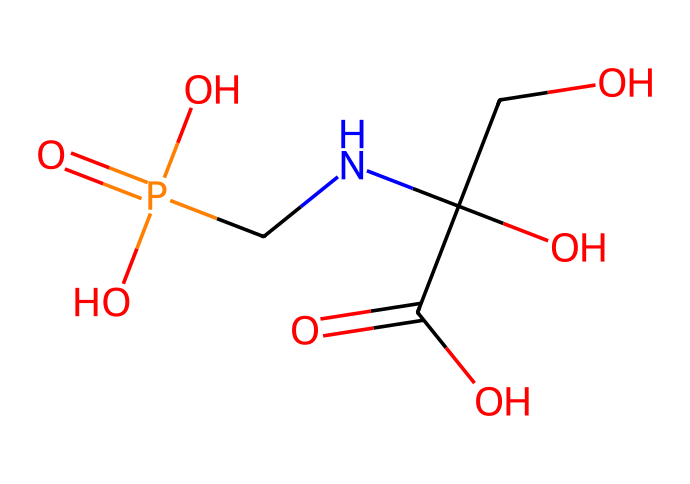How many carbon atoms are in glyphosate? The SMILES representation shows the presence of four carbon atoms in glyphosate, indicated by "C" in the structure. Counting each "C" gives the total number.
Answer: four What functional groups are present in glyphosate? Examining the SMILES, glyphosate contains a carboxylic acid (-COOH) group and an amine (-NH) group, both indicated in the structure.
Answer: carboxylic acid, amine What is the molar mass of glyphosate? By analyzing the SMILES, we can calculate the molar mass based on the number of each type of atom present (C, H, O, N, P). The calculation leads us to a total of 169.07 g/mol for glyphosate.
Answer: 169.07 g/mol What is the main functional role of glyphosate? Glyphosate acts as a broad-spectrum systemic herbicide, which is evident from its chemical structure, specifically its ability to inhibit the shikimic acid pathway in plants.
Answer: herbicide Which part of glyphosate is responsible for its herbicidal activity? The nitrogen atom in the structure serves as a crucial component for glyphosate's activity, as it interacts with the enzyme in the shikimic acid pathway, inhibiting plant growth.
Answer: nitrogen How many oxygen atoms are in glyphosate? The SMILES representation shows a total of five oxygen atoms present in glyphosate, indicated by "O" in the structure. Counting each "O" gives the total number.
Answer: five What type of bond connects the nitrogen and carbon in glyphosate? The bond type between the nitrogen and the adjacent carbon in the structure is a single covalent bond; this is supported by the absence of double or triple bond indicators in the SMILES.
Answer: single covalent bond 